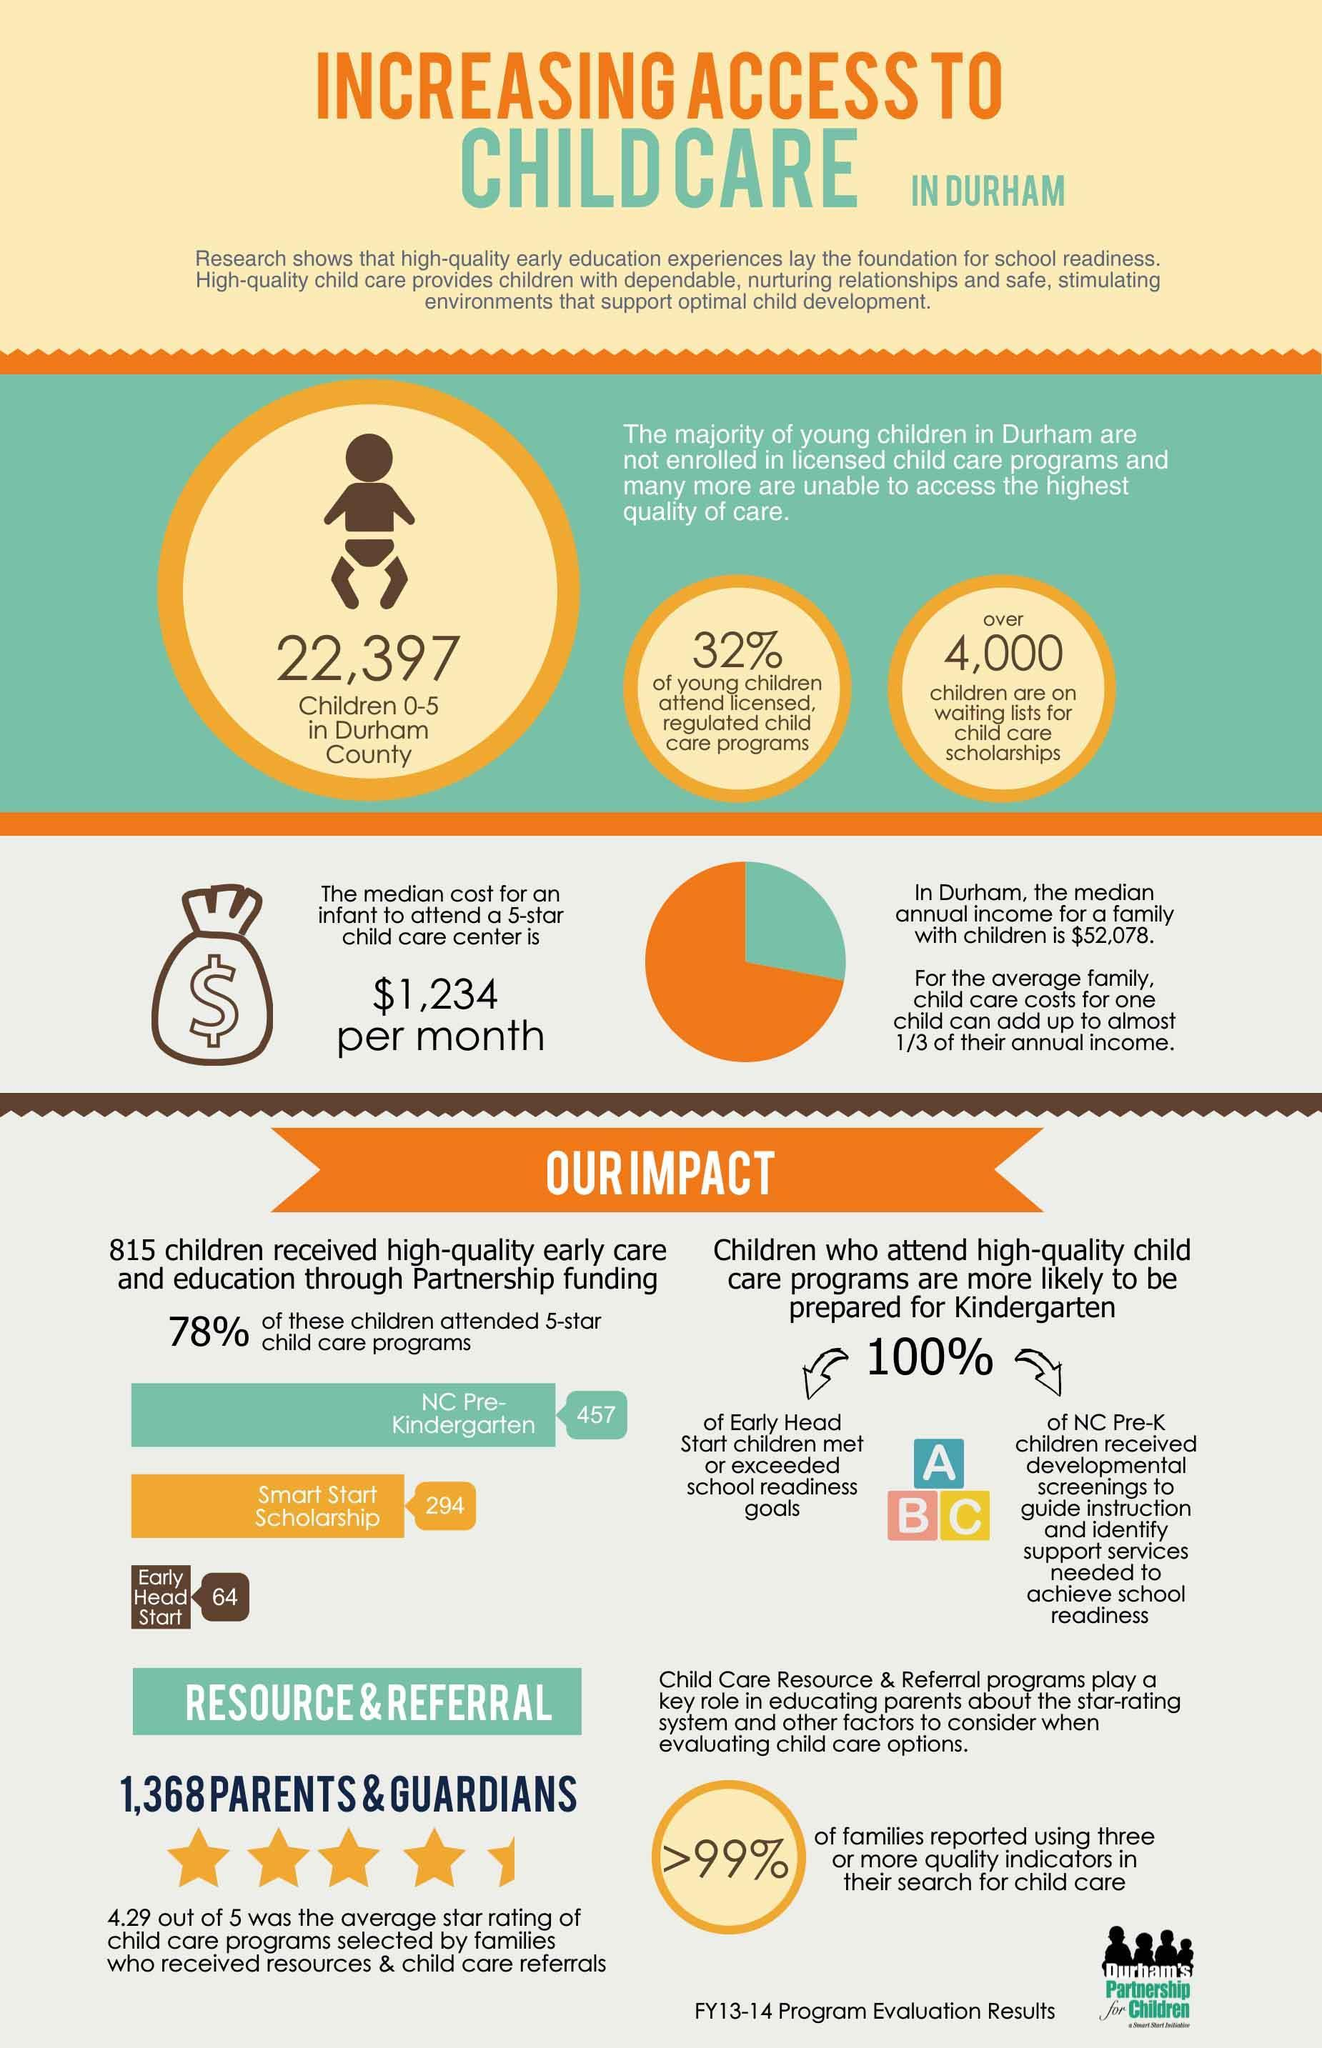What percentage of the young children in Durham attended licensed, regulated child care programs during the 2013-14 fiscal year?
Answer the question with a short phrase. 32% How many children in Durham attended the early head start program during the 2013-14 fiscal year? 64 